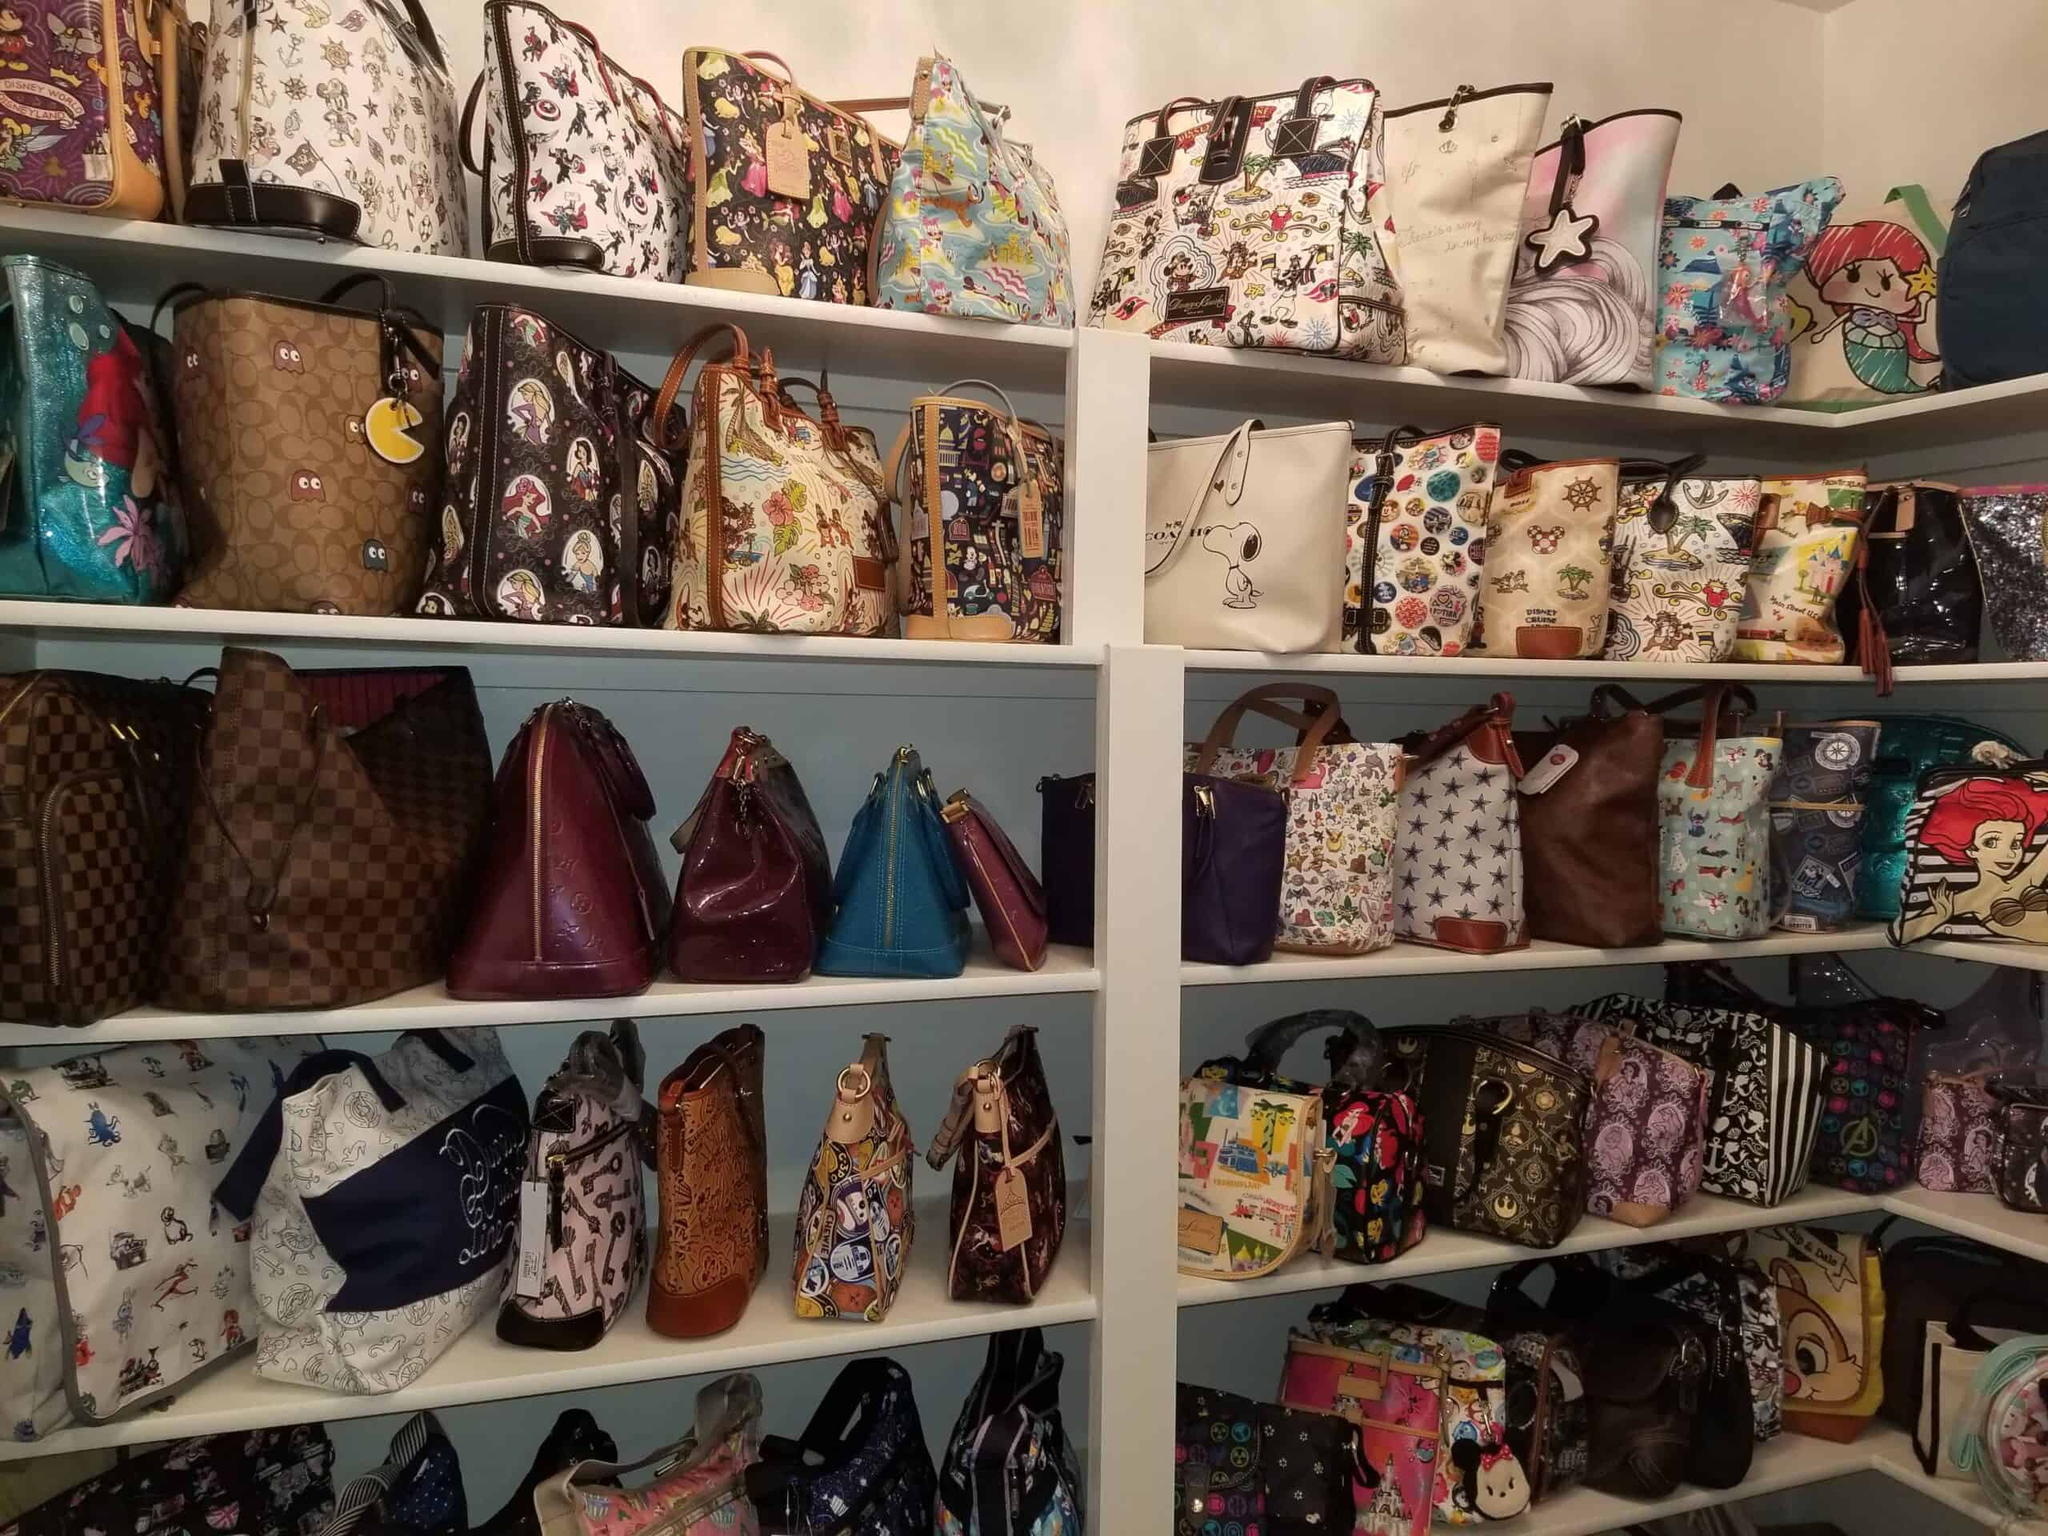What kind of events or places would these bags be suitable for? These bags would be perfect for casual outings, especially those involving fun events like comic conventions, theme park visits, or movie premieres. The themed designs make them ideal for showcasing fandom and adding a touch of personal style. Additionally, these bags could also add an element of fun to everyday use, such as school, shopping, or meeting friends for coffee.  If these bags could talk, what stories might they tell? If these bags could talk, they might share exciting stories filled with vibrant characters and their adventures. Perhaps one bag would tell of attending a thrilling comic convention, meeting creators and fans alike, while another might recount trips to various theme parks, collecting autographs and memorable moments. Some may recount cozy days at cafes listening to the chatter around, or the countless times they have been admired for their unique designs. Each bag holds memories and experiences unique to its owner and its many travels. 